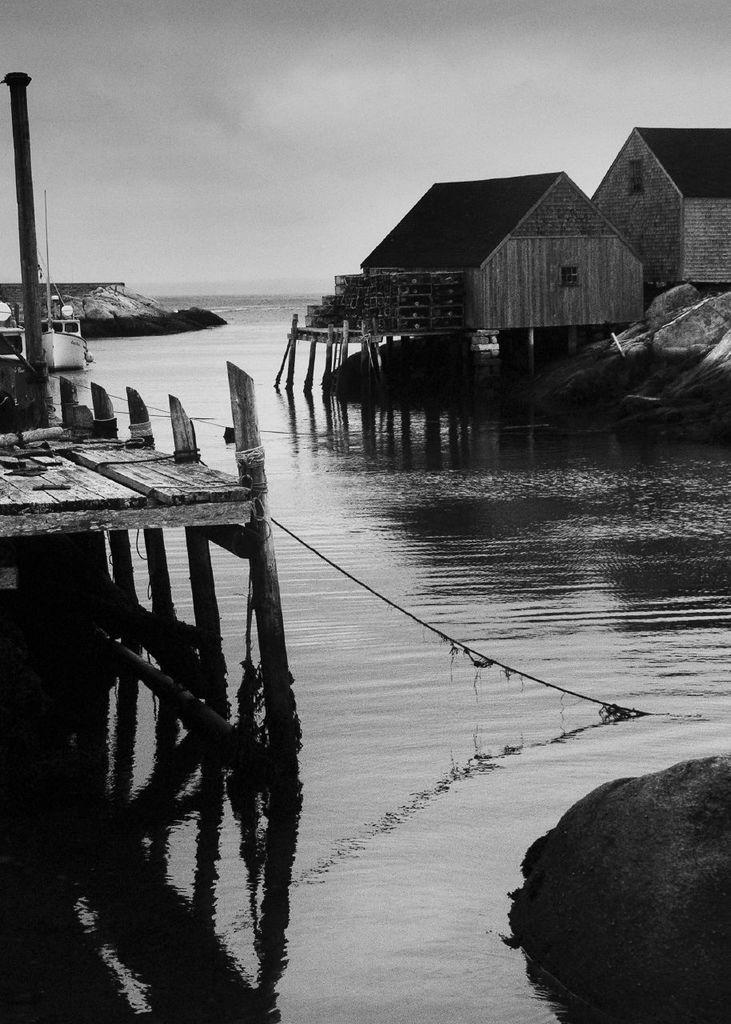What is the color scheme of the image? The image is black and white. What type of structures can be seen in the image? There are sheds in the image. What type of bridge is present in the image? There is a board bridge in the image. What type of natural feature is present in the image? There are rocks in the image. What type of vehicle is on the water in the image? There is a boat on the water in the image. What is visible at the top of the image? The sky is visible at the top of the image. Where is the twig located in the image? There is no twig present in the image. What type of bread is visible on the board bridge? There is no bread, specifically a loaf, present in the image. 